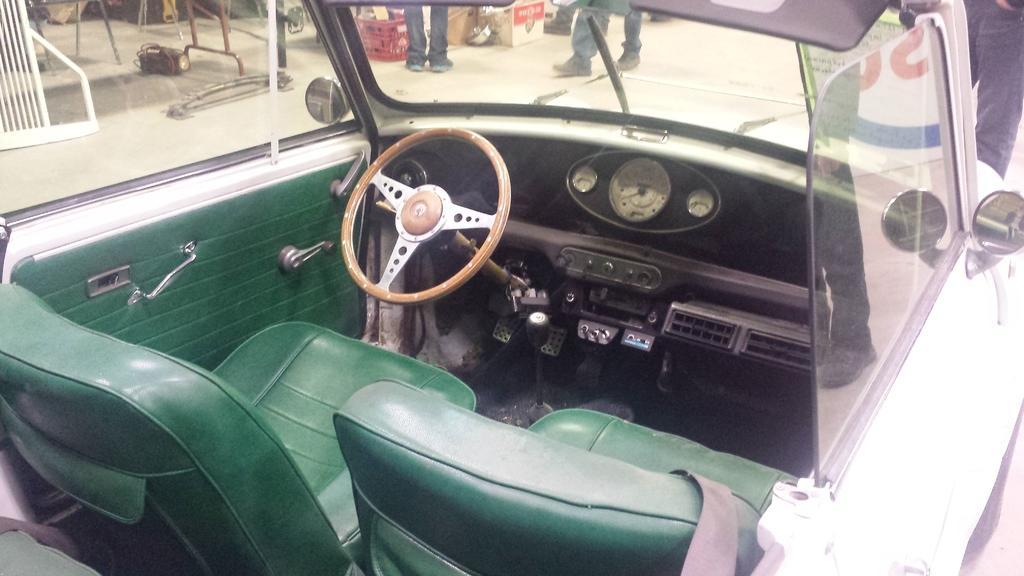How would you summarize this image in a sentence or two? In the image in the center we can see one car. In the car,there is a steering wheel,green color seats,door,window,front transparent glass,seat belt and few other objects. Through glass,we can see boxes,poles,light,fence,few people standing and few other objects. 